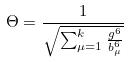Convert formula to latex. <formula><loc_0><loc_0><loc_500><loc_500>\Theta = \frac { 1 } { \sqrt { \sum _ { \mu = 1 } ^ { k } \frac { g ^ { 6 } } { b _ { \mu } ^ { 6 } } } }</formula> 